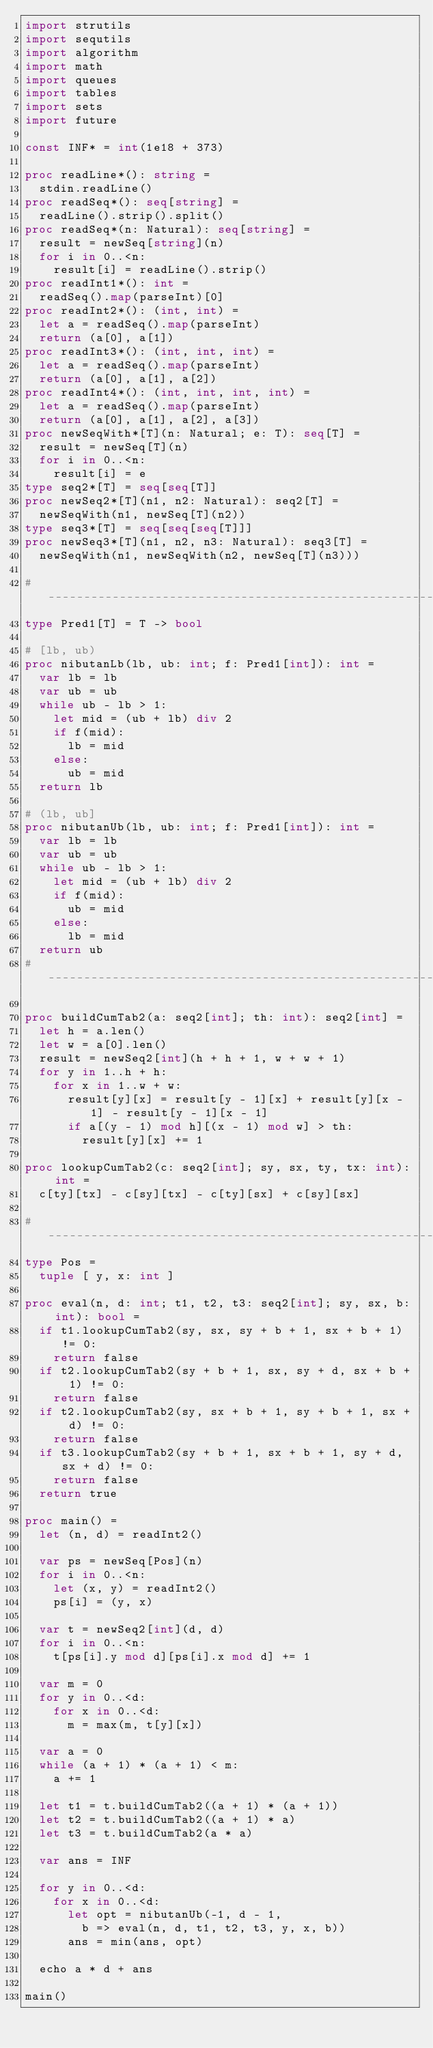<code> <loc_0><loc_0><loc_500><loc_500><_Nim_>import strutils
import sequtils
import algorithm
import math
import queues
import tables
import sets
import future

const INF* = int(1e18 + 373)

proc readLine*(): string =
  stdin.readLine()
proc readSeq*(): seq[string] =
  readLine().strip().split()
proc readSeq*(n: Natural): seq[string] =
  result = newSeq[string](n)
  for i in 0..<n:
    result[i] = readLine().strip()
proc readInt1*(): int =
  readSeq().map(parseInt)[0]
proc readInt2*(): (int, int) =
  let a = readSeq().map(parseInt)
  return (a[0], a[1])
proc readInt3*(): (int, int, int) =
  let a = readSeq().map(parseInt)
  return (a[0], a[1], a[2])
proc readInt4*(): (int, int, int, int) =
  let a = readSeq().map(parseInt)
  return (a[0], a[1], a[2], a[3])
proc newSeqWith*[T](n: Natural; e: T): seq[T] =
  result = newSeq[T](n)
  for i in 0..<n:
    result[i] = e
type seq2*[T] = seq[seq[T]]
proc newSeq2*[T](n1, n2: Natural): seq2[T] =
  newSeqWith(n1, newSeq[T](n2))
type seq3*[T] = seq[seq[seq[T]]]
proc newSeq3*[T](n1, n2, n3: Natural): seq3[T] =
  newSeqWith(n1, newSeqWith(n2, newSeq[T](n3)))

#------------------------------------------------------------------------------#
type Pred1[T] = T -> bool

# [lb, ub)
proc nibutanLb(lb, ub: int; f: Pred1[int]): int =
  var lb = lb
  var ub = ub
  while ub - lb > 1:
    let mid = (ub + lb) div 2
    if f(mid):
      lb = mid
    else:
      ub = mid
  return lb

# (lb, ub]
proc nibutanUb(lb, ub: int; f: Pred1[int]): int =
  var lb = lb
  var ub = ub
  while ub - lb > 1:
    let mid = (ub + lb) div 2
    if f(mid):
      ub = mid
    else:
      lb = mid
  return ub
#------------------------------------------------------------------------------#

proc buildCumTab2(a: seq2[int]; th: int): seq2[int] =
  let h = a.len()
  let w = a[0].len()
  result = newSeq2[int](h + h + 1, w + w + 1)
  for y in 1..h + h:
    for x in 1..w + w:
      result[y][x] = result[y - 1][x] + result[y][x - 1] - result[y - 1][x - 1]
      if a[(y - 1) mod h][(x - 1) mod w] > th:
        result[y][x] += 1

proc lookupCumTab2(c: seq2[int]; sy, sx, ty, tx: int): int =
  c[ty][tx] - c[sy][tx] - c[ty][sx] + c[sy][sx]

#------------------------------------------------------------------------------#
type Pos =
  tuple [ y, x: int ]

proc eval(n, d: int; t1, t2, t3: seq2[int]; sy, sx, b: int): bool =
  if t1.lookupCumTab2(sy, sx, sy + b + 1, sx + b + 1) != 0:
    return false
  if t2.lookupCumTab2(sy + b + 1, sx, sy + d, sx + b + 1) != 0:
    return false
  if t2.lookupCumTab2(sy, sx + b + 1, sy + b + 1, sx + d) != 0:
    return false
  if t3.lookupCumTab2(sy + b + 1, sx + b + 1, sy + d, sx + d) != 0:
    return false
  return true

proc main() =
  let (n, d) = readInt2()

  var ps = newSeq[Pos](n)
  for i in 0..<n:
    let (x, y) = readInt2()
    ps[i] = (y, x)

  var t = newSeq2[int](d, d)
  for i in 0..<n:
    t[ps[i].y mod d][ps[i].x mod d] += 1

  var m = 0
  for y in 0..<d:
    for x in 0..<d:
      m = max(m, t[y][x])

  var a = 0
  while (a + 1) * (a + 1) < m:
    a += 1

  let t1 = t.buildCumTab2((a + 1) * (a + 1))
  let t2 = t.buildCumTab2((a + 1) * a)
  let t3 = t.buildCumTab2(a * a)

  var ans = INF

  for y in 0..<d:
    for x in 0..<d:
      let opt = nibutanUb(-1, d - 1,
        b => eval(n, d, t1, t2, t3, y, x, b))
      ans = min(ans, opt)

  echo a * d + ans

main()

</code> 